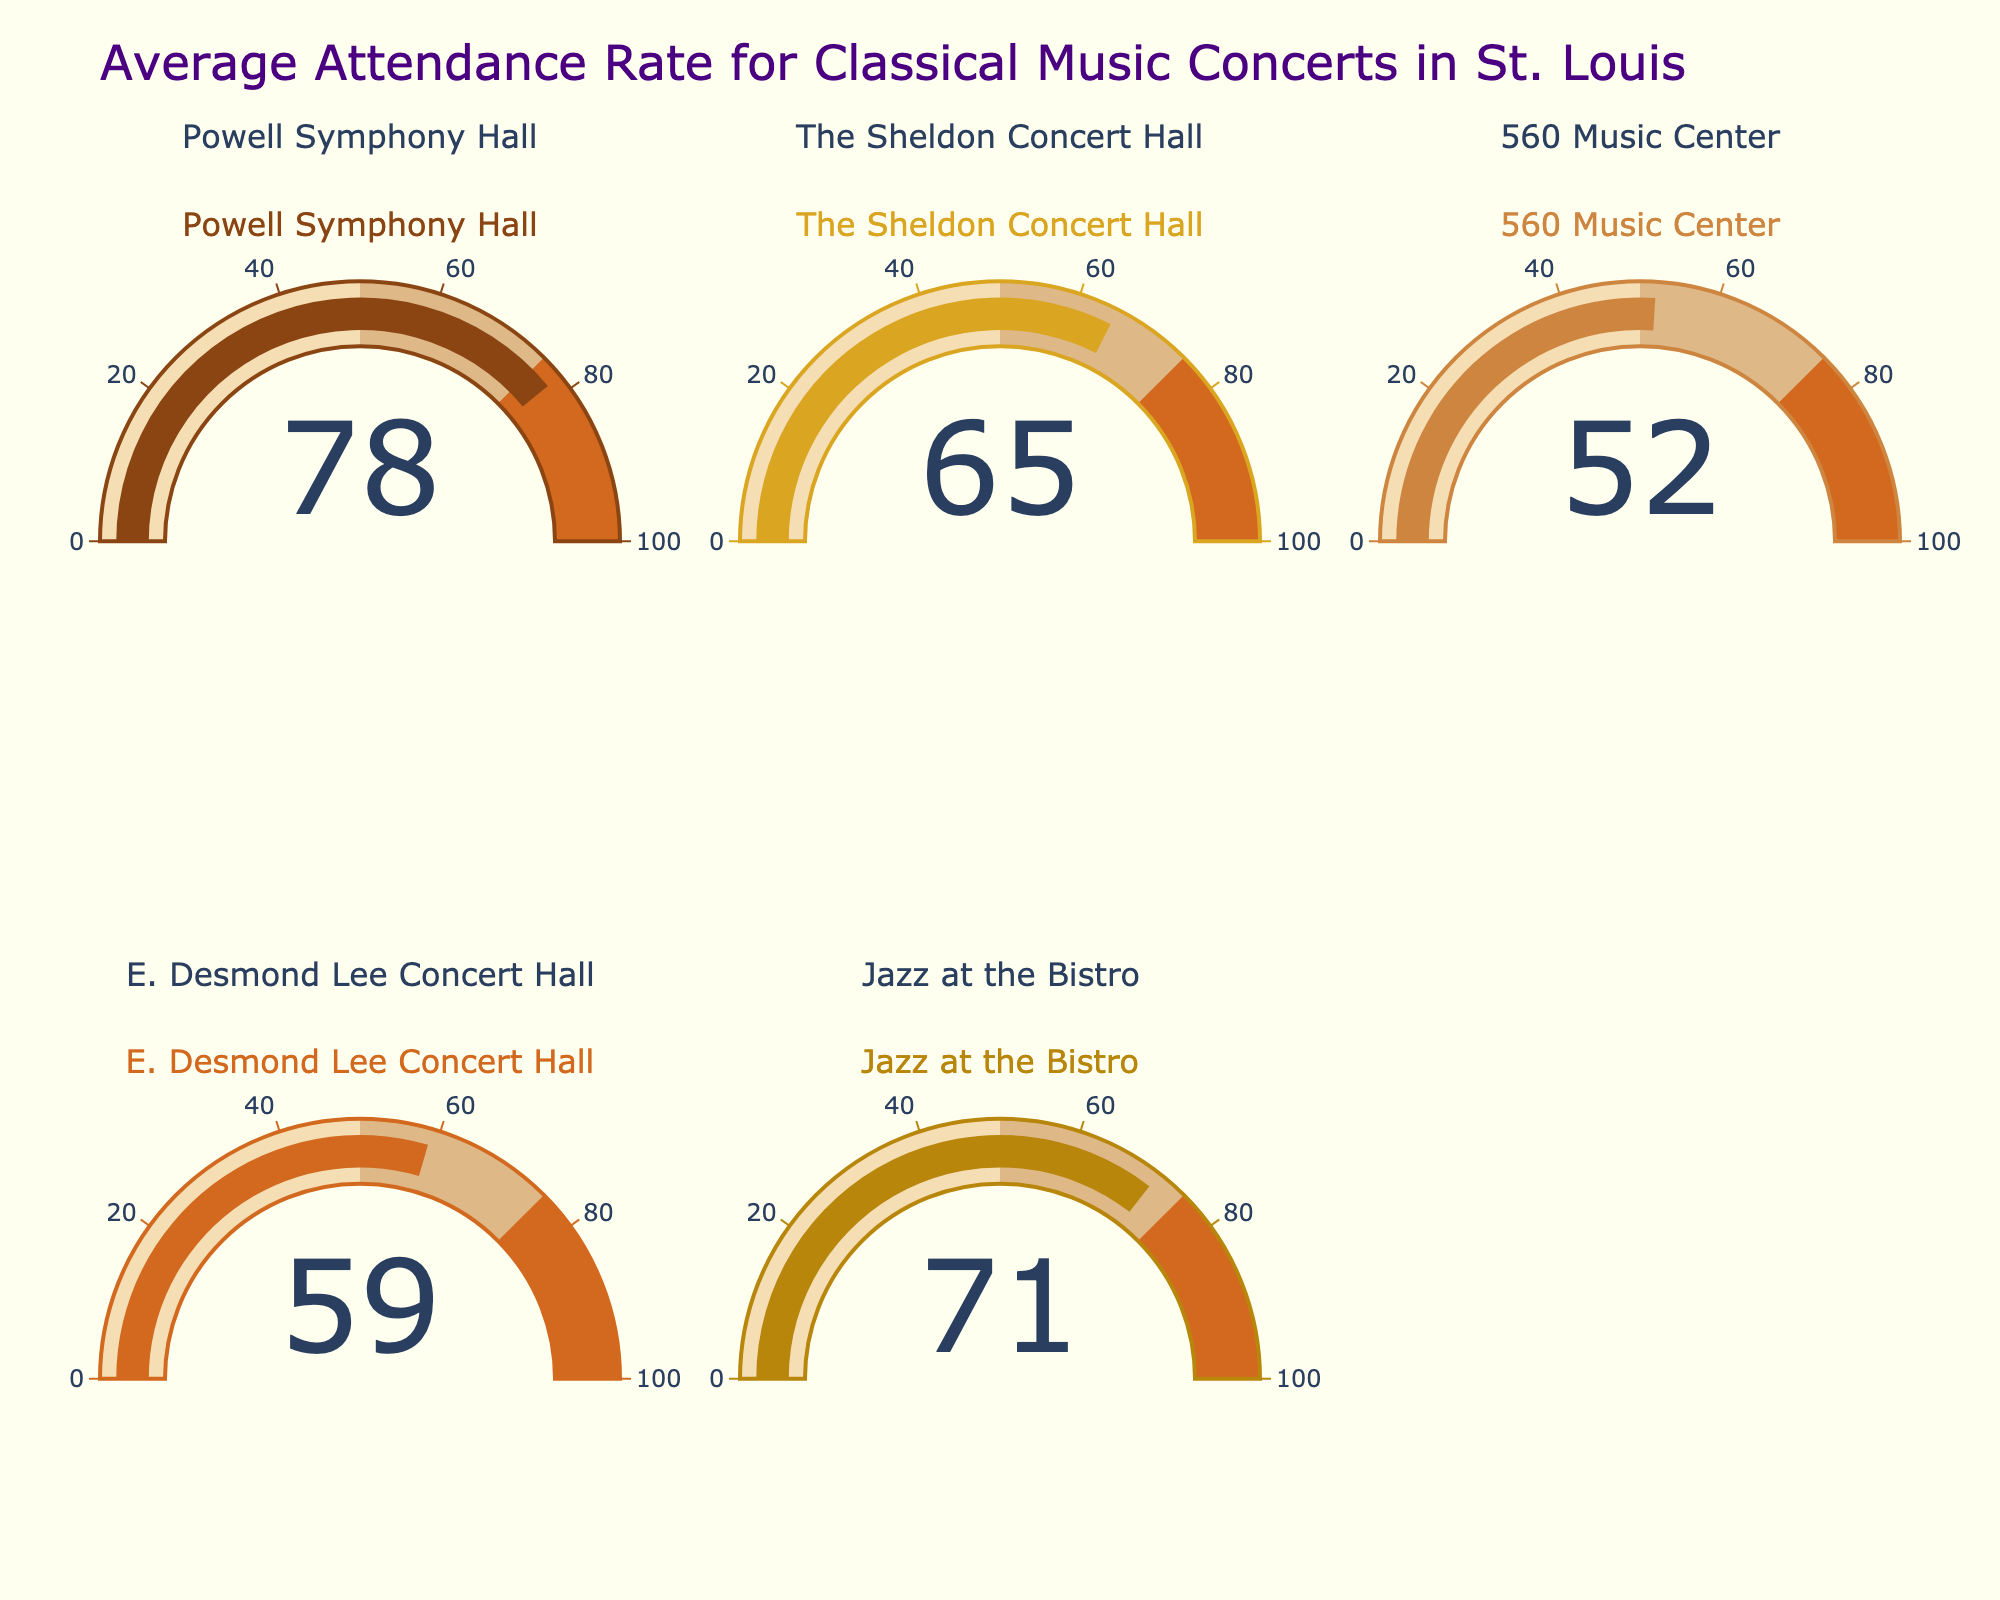Which concert hall has the highest attendance rate? Powell Symphony Hall has the highest attendance rate, as shown by the gauge indicating 78.
Answer: Powell Symphony Hall What is the lowest attendance rate shown on the figure? The gauge for 560 Music Center shows the lowest attendance rate at 52.
Answer: 52 How many concert halls have an attendance rate higher than 70? Powell Symphony Hall (78) and Jazz at the Bistro (71) both have attendance rates higher than 70, making a total of 2 concert halls.
Answer: 2 What is the average attendance rate for all concert halls? Sum all the attendance rates (78 + 65 + 52 + 59 + 71) and divide by 5: (78 + 65 + 52 + 59 + 71) / 5 = 325 / 5 = 65.
Answer: 65 Which concert hall has an attendance rate closest to the overall average? The average attendance rate is 65. The Sheldon Concert Hall has an attendance rate of 65, which is exactly equal to the average.
Answer: The Sheldon Concert Hall Between The Sheldon Concert Hall and E. Desmond Lee Concert Hall, which one has a higher attendance rate? The Sheldon Concert Hall (65) has a higher attendance rate than E. Desmond Lee Concert Hall (59).
Answer: The Sheldon Concert Hall What is the difference in attendance rate between Powell Symphony Hall and 560 Music Center? Subtract the attendance rate of 560 Music Center (52) from Powell Symphony Hall (78): 78 - 52 = 26.
Answer: 26 Which concert halls have attendance rates between 50 and 75? The Sheldon Concert Hall (65), 560 Music Center (52), E. Desmond Lee Concert Hall (59), and Jazz at the Bistro (71) have attendance rates between 50 and 75.
Answer: The Sheldon Concert Hall, 560 Music Center, E. Desmond Lee Concert Hall, Jazz at the Bistro What color is used to indicate the attendance rates on the gauge for the Powell Symphony Hall? The color used for the Powell Symphony Hall gauge is indicated by a brownish color (#8B4513).
Answer: Brownish How many gauges are shown in the figure, and how are they arranged? The figure shows 5 gauges arranged in 2 rows and 3 columns, with one empty slot in the last cell.
Answer: 5 gauges, 2 rows, 3 columns 